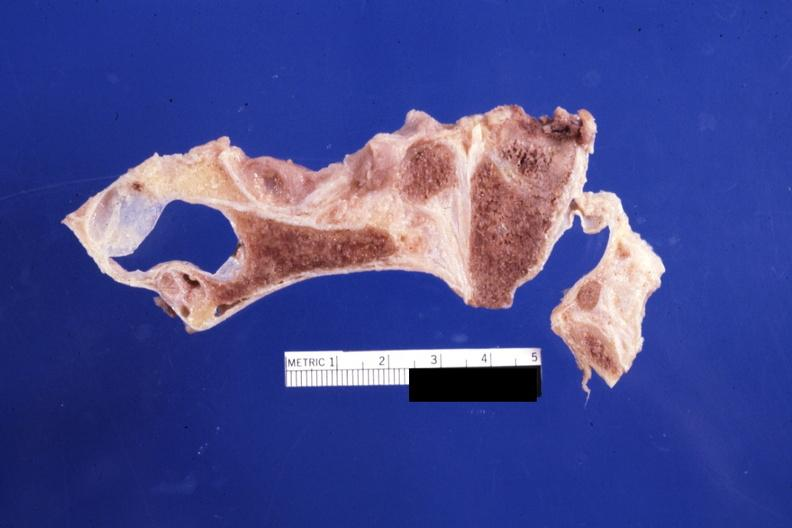what does this image show?
Answer the question using a single word or phrase. Sagittal section of atlas vertebra and occipital bone foramen magnum stenosis case 31 